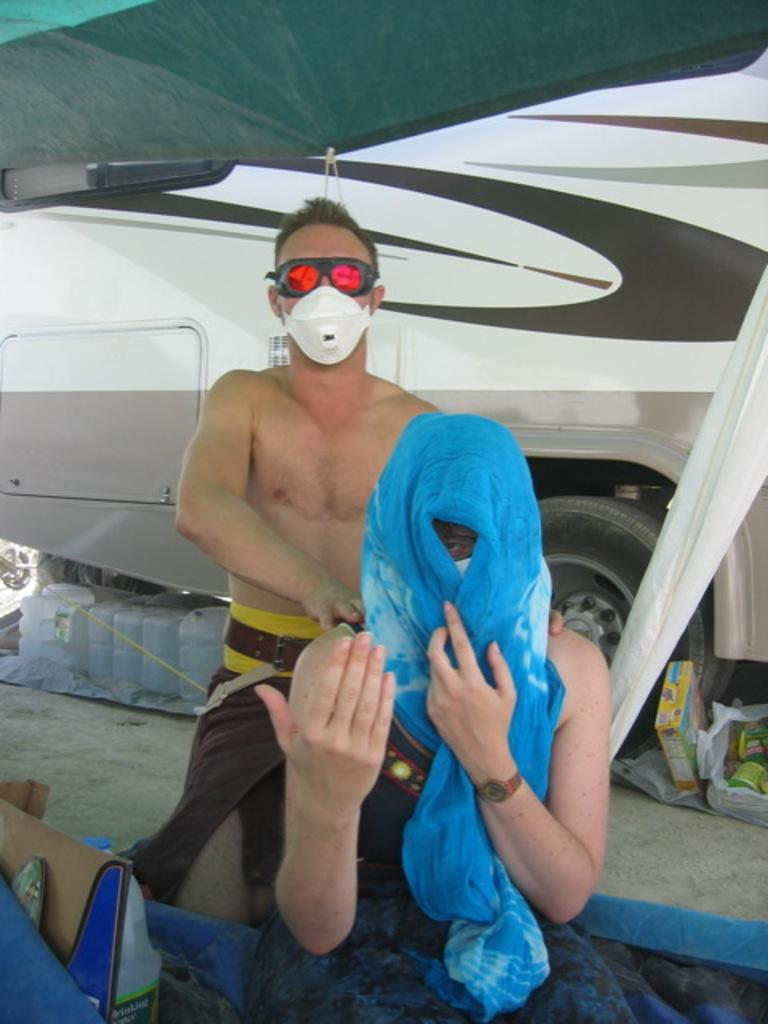How many people are present in the image? There are two people in the image. What object can be seen besides the people? There is a bag in the image. What mode of transportation is visible in the image? There is a white color bus in the image. What type of containers are present in the image? There are white color cans in the image. What type of grain is being harvested by the people in the image? There is no indication of any grain or harvesting activity in the image. 